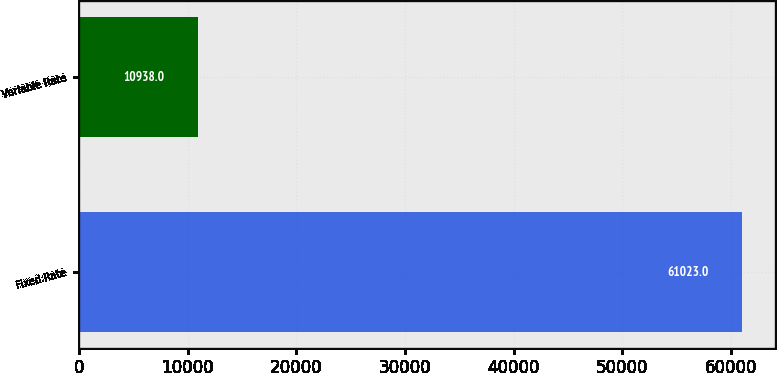Convert chart. <chart><loc_0><loc_0><loc_500><loc_500><bar_chart><fcel>Fixed Rate<fcel>Variable Rate<nl><fcel>61023<fcel>10938<nl></chart> 